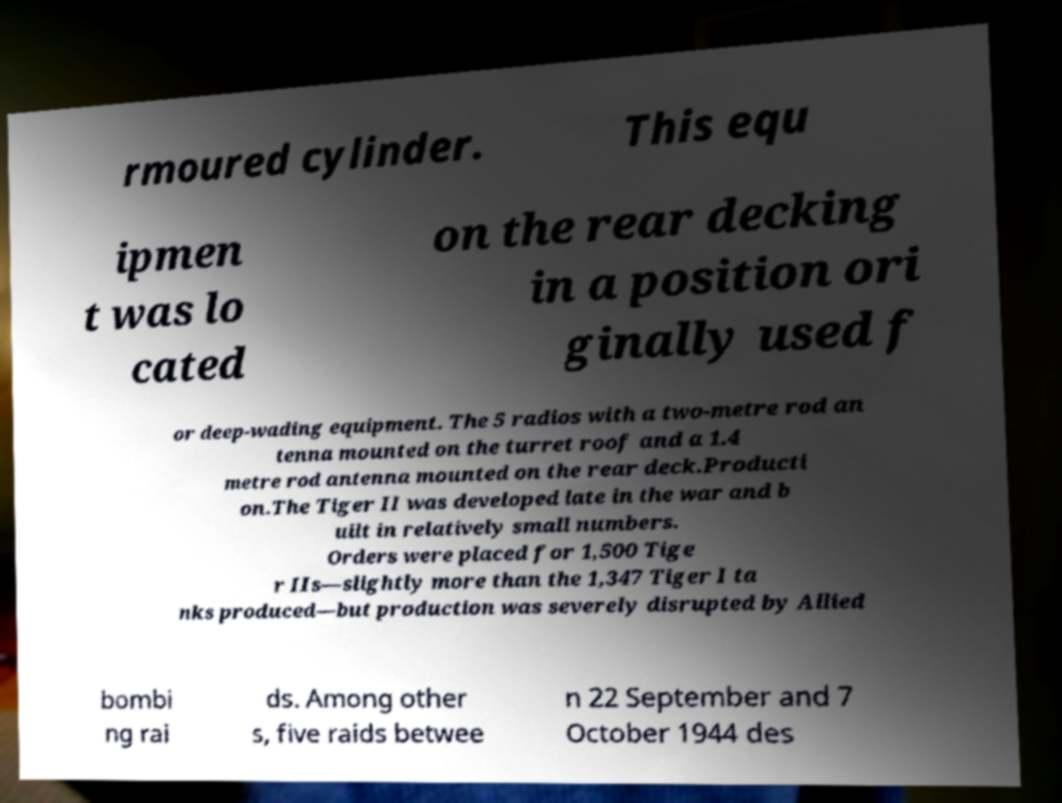There's text embedded in this image that I need extracted. Can you transcribe it verbatim? rmoured cylinder. This equ ipmen t was lo cated on the rear decking in a position ori ginally used f or deep-wading equipment. The 5 radios with a two-metre rod an tenna mounted on the turret roof and a 1.4 metre rod antenna mounted on the rear deck.Producti on.The Tiger II was developed late in the war and b uilt in relatively small numbers. Orders were placed for 1,500 Tige r IIs—slightly more than the 1,347 Tiger I ta nks produced—but production was severely disrupted by Allied bombi ng rai ds. Among other s, five raids betwee n 22 September and 7 October 1944 des 